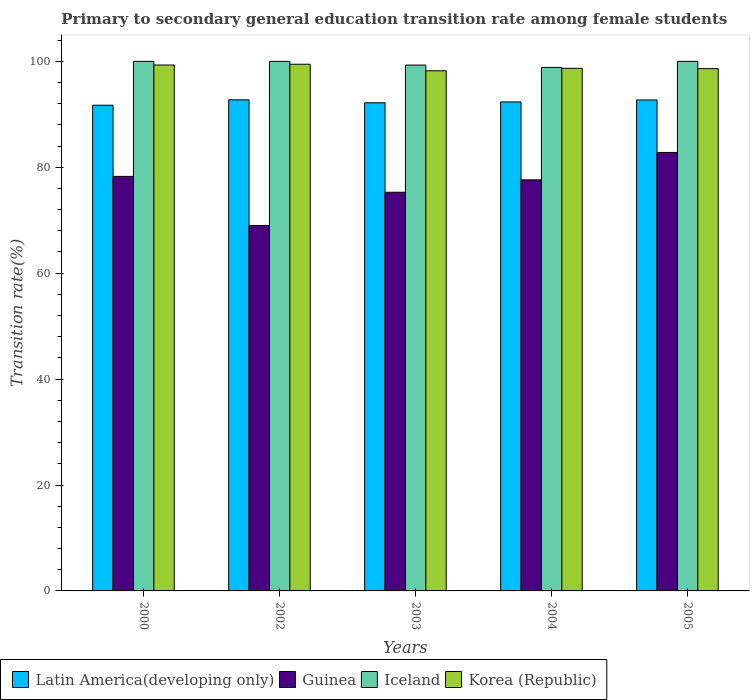How many groups of bars are there?
Provide a short and direct response. 5. Are the number of bars per tick equal to the number of legend labels?
Offer a terse response. Yes. Are the number of bars on each tick of the X-axis equal?
Your response must be concise. Yes. How many bars are there on the 2nd tick from the left?
Make the answer very short. 4. What is the label of the 1st group of bars from the left?
Provide a short and direct response. 2000. In how many cases, is the number of bars for a given year not equal to the number of legend labels?
Your answer should be very brief. 0. What is the transition rate in Korea (Republic) in 2004?
Offer a terse response. 98.69. Across all years, what is the maximum transition rate in Korea (Republic)?
Offer a very short reply. 99.46. Across all years, what is the minimum transition rate in Latin America(developing only)?
Give a very brief answer. 91.71. In which year was the transition rate in Iceland maximum?
Ensure brevity in your answer.  2000. What is the total transition rate in Iceland in the graph?
Offer a very short reply. 498.15. What is the difference between the transition rate in Iceland in 2003 and that in 2005?
Offer a very short reply. -0.71. What is the difference between the transition rate in Korea (Republic) in 2005 and the transition rate in Latin America(developing only) in 2003?
Provide a short and direct response. 6.45. What is the average transition rate in Korea (Republic) per year?
Ensure brevity in your answer.  98.86. In the year 2002, what is the difference between the transition rate in Latin America(developing only) and transition rate in Korea (Republic)?
Provide a short and direct response. -6.72. In how many years, is the transition rate in Latin America(developing only) greater than 20 %?
Your answer should be very brief. 5. What is the ratio of the transition rate in Guinea in 2000 to that in 2003?
Give a very brief answer. 1.04. What is the difference between the highest and the second highest transition rate in Guinea?
Offer a terse response. 4.52. What is the difference between the highest and the lowest transition rate in Guinea?
Keep it short and to the point. 13.79. Is it the case that in every year, the sum of the transition rate in Korea (Republic) and transition rate in Latin America(developing only) is greater than the sum of transition rate in Guinea and transition rate in Iceland?
Make the answer very short. No. What does the 3rd bar from the left in 2000 represents?
Your answer should be very brief. Iceland. What does the 1st bar from the right in 2004 represents?
Your response must be concise. Korea (Republic). Is it the case that in every year, the sum of the transition rate in Latin America(developing only) and transition rate in Guinea is greater than the transition rate in Korea (Republic)?
Make the answer very short. Yes. How many bars are there?
Make the answer very short. 20. What is the difference between two consecutive major ticks on the Y-axis?
Offer a very short reply. 20. Are the values on the major ticks of Y-axis written in scientific E-notation?
Provide a succinct answer. No. Does the graph contain any zero values?
Provide a short and direct response. No. Does the graph contain grids?
Ensure brevity in your answer.  No. Where does the legend appear in the graph?
Your answer should be very brief. Bottom left. How are the legend labels stacked?
Offer a terse response. Horizontal. What is the title of the graph?
Your answer should be very brief. Primary to secondary general education transition rate among female students. Does "Zimbabwe" appear as one of the legend labels in the graph?
Your answer should be compact. No. What is the label or title of the Y-axis?
Your answer should be compact. Transition rate(%). What is the Transition rate(%) in Latin America(developing only) in 2000?
Offer a terse response. 91.71. What is the Transition rate(%) in Guinea in 2000?
Offer a very short reply. 78.28. What is the Transition rate(%) in Iceland in 2000?
Your response must be concise. 100. What is the Transition rate(%) in Korea (Republic) in 2000?
Offer a terse response. 99.31. What is the Transition rate(%) in Latin America(developing only) in 2002?
Keep it short and to the point. 92.73. What is the Transition rate(%) of Guinea in 2002?
Your answer should be very brief. 69.01. What is the Transition rate(%) in Iceland in 2002?
Ensure brevity in your answer.  100. What is the Transition rate(%) in Korea (Republic) in 2002?
Keep it short and to the point. 99.46. What is the Transition rate(%) in Latin America(developing only) in 2003?
Your answer should be very brief. 92.18. What is the Transition rate(%) in Guinea in 2003?
Keep it short and to the point. 75.28. What is the Transition rate(%) of Iceland in 2003?
Your answer should be compact. 99.29. What is the Transition rate(%) in Korea (Republic) in 2003?
Your response must be concise. 98.22. What is the Transition rate(%) in Latin America(developing only) in 2004?
Your answer should be very brief. 92.34. What is the Transition rate(%) in Guinea in 2004?
Your response must be concise. 77.62. What is the Transition rate(%) in Iceland in 2004?
Provide a short and direct response. 98.86. What is the Transition rate(%) in Korea (Republic) in 2004?
Ensure brevity in your answer.  98.69. What is the Transition rate(%) in Latin America(developing only) in 2005?
Make the answer very short. 92.71. What is the Transition rate(%) in Guinea in 2005?
Offer a very short reply. 82.8. What is the Transition rate(%) of Korea (Republic) in 2005?
Offer a very short reply. 98.62. Across all years, what is the maximum Transition rate(%) of Latin America(developing only)?
Provide a short and direct response. 92.73. Across all years, what is the maximum Transition rate(%) in Guinea?
Your answer should be compact. 82.8. Across all years, what is the maximum Transition rate(%) in Korea (Republic)?
Keep it short and to the point. 99.46. Across all years, what is the minimum Transition rate(%) of Latin America(developing only)?
Offer a very short reply. 91.71. Across all years, what is the minimum Transition rate(%) in Guinea?
Your answer should be compact. 69.01. Across all years, what is the minimum Transition rate(%) of Iceland?
Provide a short and direct response. 98.86. Across all years, what is the minimum Transition rate(%) of Korea (Republic)?
Offer a very short reply. 98.22. What is the total Transition rate(%) in Latin America(developing only) in the graph?
Provide a short and direct response. 461.67. What is the total Transition rate(%) of Guinea in the graph?
Make the answer very short. 382.99. What is the total Transition rate(%) of Iceland in the graph?
Offer a terse response. 498.15. What is the total Transition rate(%) of Korea (Republic) in the graph?
Provide a succinct answer. 494.3. What is the difference between the Transition rate(%) in Latin America(developing only) in 2000 and that in 2002?
Provide a short and direct response. -1.02. What is the difference between the Transition rate(%) of Guinea in 2000 and that in 2002?
Offer a terse response. 9.27. What is the difference between the Transition rate(%) in Iceland in 2000 and that in 2002?
Ensure brevity in your answer.  0. What is the difference between the Transition rate(%) of Korea (Republic) in 2000 and that in 2002?
Your answer should be very brief. -0.15. What is the difference between the Transition rate(%) of Latin America(developing only) in 2000 and that in 2003?
Your answer should be compact. -0.46. What is the difference between the Transition rate(%) of Guinea in 2000 and that in 2003?
Ensure brevity in your answer.  3. What is the difference between the Transition rate(%) in Iceland in 2000 and that in 2003?
Give a very brief answer. 0.71. What is the difference between the Transition rate(%) of Korea (Republic) in 2000 and that in 2003?
Give a very brief answer. 1.09. What is the difference between the Transition rate(%) in Latin America(developing only) in 2000 and that in 2004?
Your answer should be compact. -0.62. What is the difference between the Transition rate(%) of Guinea in 2000 and that in 2004?
Give a very brief answer. 0.66. What is the difference between the Transition rate(%) in Iceland in 2000 and that in 2004?
Keep it short and to the point. 1.14. What is the difference between the Transition rate(%) in Korea (Republic) in 2000 and that in 2004?
Offer a very short reply. 0.62. What is the difference between the Transition rate(%) of Latin America(developing only) in 2000 and that in 2005?
Provide a short and direct response. -1. What is the difference between the Transition rate(%) of Guinea in 2000 and that in 2005?
Offer a terse response. -4.52. What is the difference between the Transition rate(%) in Korea (Republic) in 2000 and that in 2005?
Provide a short and direct response. 0.69. What is the difference between the Transition rate(%) of Latin America(developing only) in 2002 and that in 2003?
Your answer should be compact. 0.56. What is the difference between the Transition rate(%) of Guinea in 2002 and that in 2003?
Ensure brevity in your answer.  -6.27. What is the difference between the Transition rate(%) in Iceland in 2002 and that in 2003?
Offer a terse response. 0.71. What is the difference between the Transition rate(%) in Korea (Republic) in 2002 and that in 2003?
Offer a very short reply. 1.23. What is the difference between the Transition rate(%) in Latin America(developing only) in 2002 and that in 2004?
Provide a short and direct response. 0.4. What is the difference between the Transition rate(%) in Guinea in 2002 and that in 2004?
Your answer should be very brief. -8.61. What is the difference between the Transition rate(%) of Iceland in 2002 and that in 2004?
Offer a very short reply. 1.14. What is the difference between the Transition rate(%) in Korea (Republic) in 2002 and that in 2004?
Offer a very short reply. 0.77. What is the difference between the Transition rate(%) of Latin America(developing only) in 2002 and that in 2005?
Ensure brevity in your answer.  0.02. What is the difference between the Transition rate(%) of Guinea in 2002 and that in 2005?
Offer a very short reply. -13.79. What is the difference between the Transition rate(%) in Iceland in 2002 and that in 2005?
Ensure brevity in your answer.  0. What is the difference between the Transition rate(%) of Korea (Republic) in 2002 and that in 2005?
Offer a very short reply. 0.83. What is the difference between the Transition rate(%) of Latin America(developing only) in 2003 and that in 2004?
Keep it short and to the point. -0.16. What is the difference between the Transition rate(%) of Guinea in 2003 and that in 2004?
Ensure brevity in your answer.  -2.34. What is the difference between the Transition rate(%) in Iceland in 2003 and that in 2004?
Offer a very short reply. 0.44. What is the difference between the Transition rate(%) of Korea (Republic) in 2003 and that in 2004?
Your answer should be compact. -0.47. What is the difference between the Transition rate(%) of Latin America(developing only) in 2003 and that in 2005?
Make the answer very short. -0.54. What is the difference between the Transition rate(%) of Guinea in 2003 and that in 2005?
Offer a very short reply. -7.52. What is the difference between the Transition rate(%) in Iceland in 2003 and that in 2005?
Offer a terse response. -0.71. What is the difference between the Transition rate(%) in Korea (Republic) in 2003 and that in 2005?
Your answer should be very brief. -0.4. What is the difference between the Transition rate(%) in Latin America(developing only) in 2004 and that in 2005?
Your answer should be compact. -0.38. What is the difference between the Transition rate(%) in Guinea in 2004 and that in 2005?
Offer a terse response. -5.18. What is the difference between the Transition rate(%) in Iceland in 2004 and that in 2005?
Provide a short and direct response. -1.14. What is the difference between the Transition rate(%) of Korea (Republic) in 2004 and that in 2005?
Provide a succinct answer. 0.06. What is the difference between the Transition rate(%) of Latin America(developing only) in 2000 and the Transition rate(%) of Guinea in 2002?
Provide a short and direct response. 22.71. What is the difference between the Transition rate(%) in Latin America(developing only) in 2000 and the Transition rate(%) in Iceland in 2002?
Your answer should be compact. -8.29. What is the difference between the Transition rate(%) of Latin America(developing only) in 2000 and the Transition rate(%) of Korea (Republic) in 2002?
Offer a very short reply. -7.74. What is the difference between the Transition rate(%) of Guinea in 2000 and the Transition rate(%) of Iceland in 2002?
Your answer should be very brief. -21.72. What is the difference between the Transition rate(%) in Guinea in 2000 and the Transition rate(%) in Korea (Republic) in 2002?
Keep it short and to the point. -21.18. What is the difference between the Transition rate(%) in Iceland in 2000 and the Transition rate(%) in Korea (Republic) in 2002?
Ensure brevity in your answer.  0.54. What is the difference between the Transition rate(%) of Latin America(developing only) in 2000 and the Transition rate(%) of Guinea in 2003?
Provide a succinct answer. 16.43. What is the difference between the Transition rate(%) in Latin America(developing only) in 2000 and the Transition rate(%) in Iceland in 2003?
Keep it short and to the point. -7.58. What is the difference between the Transition rate(%) of Latin America(developing only) in 2000 and the Transition rate(%) of Korea (Republic) in 2003?
Offer a terse response. -6.51. What is the difference between the Transition rate(%) of Guinea in 2000 and the Transition rate(%) of Iceland in 2003?
Provide a short and direct response. -21.01. What is the difference between the Transition rate(%) in Guinea in 2000 and the Transition rate(%) in Korea (Republic) in 2003?
Provide a short and direct response. -19.94. What is the difference between the Transition rate(%) in Iceland in 2000 and the Transition rate(%) in Korea (Republic) in 2003?
Your answer should be very brief. 1.78. What is the difference between the Transition rate(%) in Latin America(developing only) in 2000 and the Transition rate(%) in Guinea in 2004?
Keep it short and to the point. 14.09. What is the difference between the Transition rate(%) in Latin America(developing only) in 2000 and the Transition rate(%) in Iceland in 2004?
Provide a short and direct response. -7.14. What is the difference between the Transition rate(%) in Latin America(developing only) in 2000 and the Transition rate(%) in Korea (Republic) in 2004?
Your answer should be compact. -6.97. What is the difference between the Transition rate(%) in Guinea in 2000 and the Transition rate(%) in Iceland in 2004?
Your answer should be compact. -20.58. What is the difference between the Transition rate(%) of Guinea in 2000 and the Transition rate(%) of Korea (Republic) in 2004?
Provide a succinct answer. -20.41. What is the difference between the Transition rate(%) in Iceland in 2000 and the Transition rate(%) in Korea (Republic) in 2004?
Offer a terse response. 1.31. What is the difference between the Transition rate(%) of Latin America(developing only) in 2000 and the Transition rate(%) of Guinea in 2005?
Provide a short and direct response. 8.92. What is the difference between the Transition rate(%) in Latin America(developing only) in 2000 and the Transition rate(%) in Iceland in 2005?
Make the answer very short. -8.29. What is the difference between the Transition rate(%) in Latin America(developing only) in 2000 and the Transition rate(%) in Korea (Republic) in 2005?
Make the answer very short. -6.91. What is the difference between the Transition rate(%) in Guinea in 2000 and the Transition rate(%) in Iceland in 2005?
Give a very brief answer. -21.72. What is the difference between the Transition rate(%) in Guinea in 2000 and the Transition rate(%) in Korea (Republic) in 2005?
Your response must be concise. -20.34. What is the difference between the Transition rate(%) of Iceland in 2000 and the Transition rate(%) of Korea (Republic) in 2005?
Keep it short and to the point. 1.38. What is the difference between the Transition rate(%) in Latin America(developing only) in 2002 and the Transition rate(%) in Guinea in 2003?
Ensure brevity in your answer.  17.45. What is the difference between the Transition rate(%) in Latin America(developing only) in 2002 and the Transition rate(%) in Iceland in 2003?
Offer a very short reply. -6.56. What is the difference between the Transition rate(%) in Latin America(developing only) in 2002 and the Transition rate(%) in Korea (Republic) in 2003?
Your response must be concise. -5.49. What is the difference between the Transition rate(%) of Guinea in 2002 and the Transition rate(%) of Iceland in 2003?
Provide a succinct answer. -30.29. What is the difference between the Transition rate(%) in Guinea in 2002 and the Transition rate(%) in Korea (Republic) in 2003?
Your response must be concise. -29.21. What is the difference between the Transition rate(%) in Iceland in 2002 and the Transition rate(%) in Korea (Republic) in 2003?
Keep it short and to the point. 1.78. What is the difference between the Transition rate(%) of Latin America(developing only) in 2002 and the Transition rate(%) of Guinea in 2004?
Give a very brief answer. 15.11. What is the difference between the Transition rate(%) of Latin America(developing only) in 2002 and the Transition rate(%) of Iceland in 2004?
Your response must be concise. -6.12. What is the difference between the Transition rate(%) in Latin America(developing only) in 2002 and the Transition rate(%) in Korea (Republic) in 2004?
Ensure brevity in your answer.  -5.95. What is the difference between the Transition rate(%) of Guinea in 2002 and the Transition rate(%) of Iceland in 2004?
Your response must be concise. -29.85. What is the difference between the Transition rate(%) of Guinea in 2002 and the Transition rate(%) of Korea (Republic) in 2004?
Offer a terse response. -29.68. What is the difference between the Transition rate(%) of Iceland in 2002 and the Transition rate(%) of Korea (Republic) in 2004?
Provide a short and direct response. 1.31. What is the difference between the Transition rate(%) of Latin America(developing only) in 2002 and the Transition rate(%) of Guinea in 2005?
Your answer should be very brief. 9.94. What is the difference between the Transition rate(%) in Latin America(developing only) in 2002 and the Transition rate(%) in Iceland in 2005?
Offer a terse response. -7.27. What is the difference between the Transition rate(%) of Latin America(developing only) in 2002 and the Transition rate(%) of Korea (Republic) in 2005?
Keep it short and to the point. -5.89. What is the difference between the Transition rate(%) in Guinea in 2002 and the Transition rate(%) in Iceland in 2005?
Your answer should be very brief. -30.99. What is the difference between the Transition rate(%) of Guinea in 2002 and the Transition rate(%) of Korea (Republic) in 2005?
Keep it short and to the point. -29.61. What is the difference between the Transition rate(%) in Iceland in 2002 and the Transition rate(%) in Korea (Republic) in 2005?
Your answer should be very brief. 1.38. What is the difference between the Transition rate(%) of Latin America(developing only) in 2003 and the Transition rate(%) of Guinea in 2004?
Make the answer very short. 14.56. What is the difference between the Transition rate(%) of Latin America(developing only) in 2003 and the Transition rate(%) of Iceland in 2004?
Your answer should be compact. -6.68. What is the difference between the Transition rate(%) of Latin America(developing only) in 2003 and the Transition rate(%) of Korea (Republic) in 2004?
Provide a short and direct response. -6.51. What is the difference between the Transition rate(%) in Guinea in 2003 and the Transition rate(%) in Iceland in 2004?
Your answer should be very brief. -23.58. What is the difference between the Transition rate(%) of Guinea in 2003 and the Transition rate(%) of Korea (Republic) in 2004?
Provide a short and direct response. -23.41. What is the difference between the Transition rate(%) of Iceland in 2003 and the Transition rate(%) of Korea (Republic) in 2004?
Your answer should be very brief. 0.61. What is the difference between the Transition rate(%) in Latin America(developing only) in 2003 and the Transition rate(%) in Guinea in 2005?
Offer a very short reply. 9.38. What is the difference between the Transition rate(%) of Latin America(developing only) in 2003 and the Transition rate(%) of Iceland in 2005?
Offer a very short reply. -7.82. What is the difference between the Transition rate(%) in Latin America(developing only) in 2003 and the Transition rate(%) in Korea (Republic) in 2005?
Provide a short and direct response. -6.45. What is the difference between the Transition rate(%) of Guinea in 2003 and the Transition rate(%) of Iceland in 2005?
Provide a succinct answer. -24.72. What is the difference between the Transition rate(%) in Guinea in 2003 and the Transition rate(%) in Korea (Republic) in 2005?
Give a very brief answer. -23.34. What is the difference between the Transition rate(%) of Iceland in 2003 and the Transition rate(%) of Korea (Republic) in 2005?
Keep it short and to the point. 0.67. What is the difference between the Transition rate(%) in Latin America(developing only) in 2004 and the Transition rate(%) in Guinea in 2005?
Your response must be concise. 9.54. What is the difference between the Transition rate(%) of Latin America(developing only) in 2004 and the Transition rate(%) of Iceland in 2005?
Offer a very short reply. -7.66. What is the difference between the Transition rate(%) of Latin America(developing only) in 2004 and the Transition rate(%) of Korea (Republic) in 2005?
Offer a terse response. -6.29. What is the difference between the Transition rate(%) of Guinea in 2004 and the Transition rate(%) of Iceland in 2005?
Your answer should be very brief. -22.38. What is the difference between the Transition rate(%) of Guinea in 2004 and the Transition rate(%) of Korea (Republic) in 2005?
Give a very brief answer. -21. What is the difference between the Transition rate(%) of Iceland in 2004 and the Transition rate(%) of Korea (Republic) in 2005?
Your answer should be compact. 0.23. What is the average Transition rate(%) of Latin America(developing only) per year?
Your answer should be very brief. 92.33. What is the average Transition rate(%) of Guinea per year?
Provide a short and direct response. 76.6. What is the average Transition rate(%) in Iceland per year?
Provide a succinct answer. 99.63. What is the average Transition rate(%) in Korea (Republic) per year?
Offer a very short reply. 98.86. In the year 2000, what is the difference between the Transition rate(%) in Latin America(developing only) and Transition rate(%) in Guinea?
Offer a very short reply. 13.43. In the year 2000, what is the difference between the Transition rate(%) of Latin America(developing only) and Transition rate(%) of Iceland?
Offer a very short reply. -8.29. In the year 2000, what is the difference between the Transition rate(%) of Latin America(developing only) and Transition rate(%) of Korea (Republic)?
Your answer should be very brief. -7.59. In the year 2000, what is the difference between the Transition rate(%) of Guinea and Transition rate(%) of Iceland?
Make the answer very short. -21.72. In the year 2000, what is the difference between the Transition rate(%) in Guinea and Transition rate(%) in Korea (Republic)?
Provide a short and direct response. -21.03. In the year 2000, what is the difference between the Transition rate(%) of Iceland and Transition rate(%) of Korea (Republic)?
Give a very brief answer. 0.69. In the year 2002, what is the difference between the Transition rate(%) in Latin America(developing only) and Transition rate(%) in Guinea?
Your response must be concise. 23.73. In the year 2002, what is the difference between the Transition rate(%) in Latin America(developing only) and Transition rate(%) in Iceland?
Your answer should be very brief. -7.27. In the year 2002, what is the difference between the Transition rate(%) in Latin America(developing only) and Transition rate(%) in Korea (Republic)?
Ensure brevity in your answer.  -6.72. In the year 2002, what is the difference between the Transition rate(%) of Guinea and Transition rate(%) of Iceland?
Provide a short and direct response. -30.99. In the year 2002, what is the difference between the Transition rate(%) in Guinea and Transition rate(%) in Korea (Republic)?
Ensure brevity in your answer.  -30.45. In the year 2002, what is the difference between the Transition rate(%) of Iceland and Transition rate(%) of Korea (Republic)?
Make the answer very short. 0.54. In the year 2003, what is the difference between the Transition rate(%) of Latin America(developing only) and Transition rate(%) of Guinea?
Keep it short and to the point. 16.9. In the year 2003, what is the difference between the Transition rate(%) of Latin America(developing only) and Transition rate(%) of Iceland?
Give a very brief answer. -7.12. In the year 2003, what is the difference between the Transition rate(%) in Latin America(developing only) and Transition rate(%) in Korea (Republic)?
Ensure brevity in your answer.  -6.05. In the year 2003, what is the difference between the Transition rate(%) of Guinea and Transition rate(%) of Iceland?
Offer a terse response. -24.01. In the year 2003, what is the difference between the Transition rate(%) of Guinea and Transition rate(%) of Korea (Republic)?
Keep it short and to the point. -22.94. In the year 2003, what is the difference between the Transition rate(%) of Iceland and Transition rate(%) of Korea (Republic)?
Keep it short and to the point. 1.07. In the year 2004, what is the difference between the Transition rate(%) of Latin America(developing only) and Transition rate(%) of Guinea?
Give a very brief answer. 14.72. In the year 2004, what is the difference between the Transition rate(%) of Latin America(developing only) and Transition rate(%) of Iceland?
Provide a short and direct response. -6.52. In the year 2004, what is the difference between the Transition rate(%) in Latin America(developing only) and Transition rate(%) in Korea (Republic)?
Your answer should be very brief. -6.35. In the year 2004, what is the difference between the Transition rate(%) of Guinea and Transition rate(%) of Iceland?
Your answer should be compact. -21.24. In the year 2004, what is the difference between the Transition rate(%) of Guinea and Transition rate(%) of Korea (Republic)?
Your response must be concise. -21.07. In the year 2004, what is the difference between the Transition rate(%) of Iceland and Transition rate(%) of Korea (Republic)?
Offer a very short reply. 0.17. In the year 2005, what is the difference between the Transition rate(%) in Latin America(developing only) and Transition rate(%) in Guinea?
Offer a very short reply. 9.91. In the year 2005, what is the difference between the Transition rate(%) of Latin America(developing only) and Transition rate(%) of Iceland?
Offer a very short reply. -7.29. In the year 2005, what is the difference between the Transition rate(%) of Latin America(developing only) and Transition rate(%) of Korea (Republic)?
Offer a terse response. -5.91. In the year 2005, what is the difference between the Transition rate(%) in Guinea and Transition rate(%) in Iceland?
Your answer should be compact. -17.2. In the year 2005, what is the difference between the Transition rate(%) of Guinea and Transition rate(%) of Korea (Republic)?
Your response must be concise. -15.83. In the year 2005, what is the difference between the Transition rate(%) of Iceland and Transition rate(%) of Korea (Republic)?
Your answer should be very brief. 1.38. What is the ratio of the Transition rate(%) of Guinea in 2000 to that in 2002?
Provide a succinct answer. 1.13. What is the ratio of the Transition rate(%) of Guinea in 2000 to that in 2003?
Give a very brief answer. 1.04. What is the ratio of the Transition rate(%) in Iceland in 2000 to that in 2003?
Your answer should be very brief. 1.01. What is the ratio of the Transition rate(%) in Korea (Republic) in 2000 to that in 2003?
Your response must be concise. 1.01. What is the ratio of the Transition rate(%) of Latin America(developing only) in 2000 to that in 2004?
Your answer should be very brief. 0.99. What is the ratio of the Transition rate(%) in Guinea in 2000 to that in 2004?
Your response must be concise. 1.01. What is the ratio of the Transition rate(%) of Iceland in 2000 to that in 2004?
Your answer should be very brief. 1.01. What is the ratio of the Transition rate(%) of Latin America(developing only) in 2000 to that in 2005?
Your answer should be compact. 0.99. What is the ratio of the Transition rate(%) in Guinea in 2000 to that in 2005?
Ensure brevity in your answer.  0.95. What is the ratio of the Transition rate(%) in Iceland in 2000 to that in 2005?
Provide a short and direct response. 1. What is the ratio of the Transition rate(%) in Korea (Republic) in 2000 to that in 2005?
Give a very brief answer. 1.01. What is the ratio of the Transition rate(%) in Latin America(developing only) in 2002 to that in 2003?
Your answer should be compact. 1.01. What is the ratio of the Transition rate(%) in Iceland in 2002 to that in 2003?
Offer a very short reply. 1.01. What is the ratio of the Transition rate(%) of Korea (Republic) in 2002 to that in 2003?
Offer a terse response. 1.01. What is the ratio of the Transition rate(%) of Latin America(developing only) in 2002 to that in 2004?
Make the answer very short. 1. What is the ratio of the Transition rate(%) in Guinea in 2002 to that in 2004?
Provide a short and direct response. 0.89. What is the ratio of the Transition rate(%) in Iceland in 2002 to that in 2004?
Ensure brevity in your answer.  1.01. What is the ratio of the Transition rate(%) of Korea (Republic) in 2002 to that in 2004?
Offer a very short reply. 1.01. What is the ratio of the Transition rate(%) of Latin America(developing only) in 2002 to that in 2005?
Provide a succinct answer. 1. What is the ratio of the Transition rate(%) of Guinea in 2002 to that in 2005?
Ensure brevity in your answer.  0.83. What is the ratio of the Transition rate(%) of Iceland in 2002 to that in 2005?
Offer a very short reply. 1. What is the ratio of the Transition rate(%) of Korea (Republic) in 2002 to that in 2005?
Your answer should be compact. 1.01. What is the ratio of the Transition rate(%) of Latin America(developing only) in 2003 to that in 2004?
Make the answer very short. 1. What is the ratio of the Transition rate(%) in Guinea in 2003 to that in 2004?
Your response must be concise. 0.97. What is the ratio of the Transition rate(%) in Iceland in 2003 to that in 2004?
Your answer should be very brief. 1. What is the ratio of the Transition rate(%) in Korea (Republic) in 2003 to that in 2004?
Make the answer very short. 1. What is the ratio of the Transition rate(%) of Guinea in 2003 to that in 2005?
Your answer should be very brief. 0.91. What is the ratio of the Transition rate(%) in Korea (Republic) in 2004 to that in 2005?
Provide a succinct answer. 1. What is the difference between the highest and the second highest Transition rate(%) in Latin America(developing only)?
Give a very brief answer. 0.02. What is the difference between the highest and the second highest Transition rate(%) of Guinea?
Your answer should be very brief. 4.52. What is the difference between the highest and the second highest Transition rate(%) in Iceland?
Give a very brief answer. 0. What is the difference between the highest and the second highest Transition rate(%) of Korea (Republic)?
Offer a terse response. 0.15. What is the difference between the highest and the lowest Transition rate(%) in Guinea?
Make the answer very short. 13.79. What is the difference between the highest and the lowest Transition rate(%) in Iceland?
Your answer should be very brief. 1.14. What is the difference between the highest and the lowest Transition rate(%) in Korea (Republic)?
Provide a short and direct response. 1.23. 